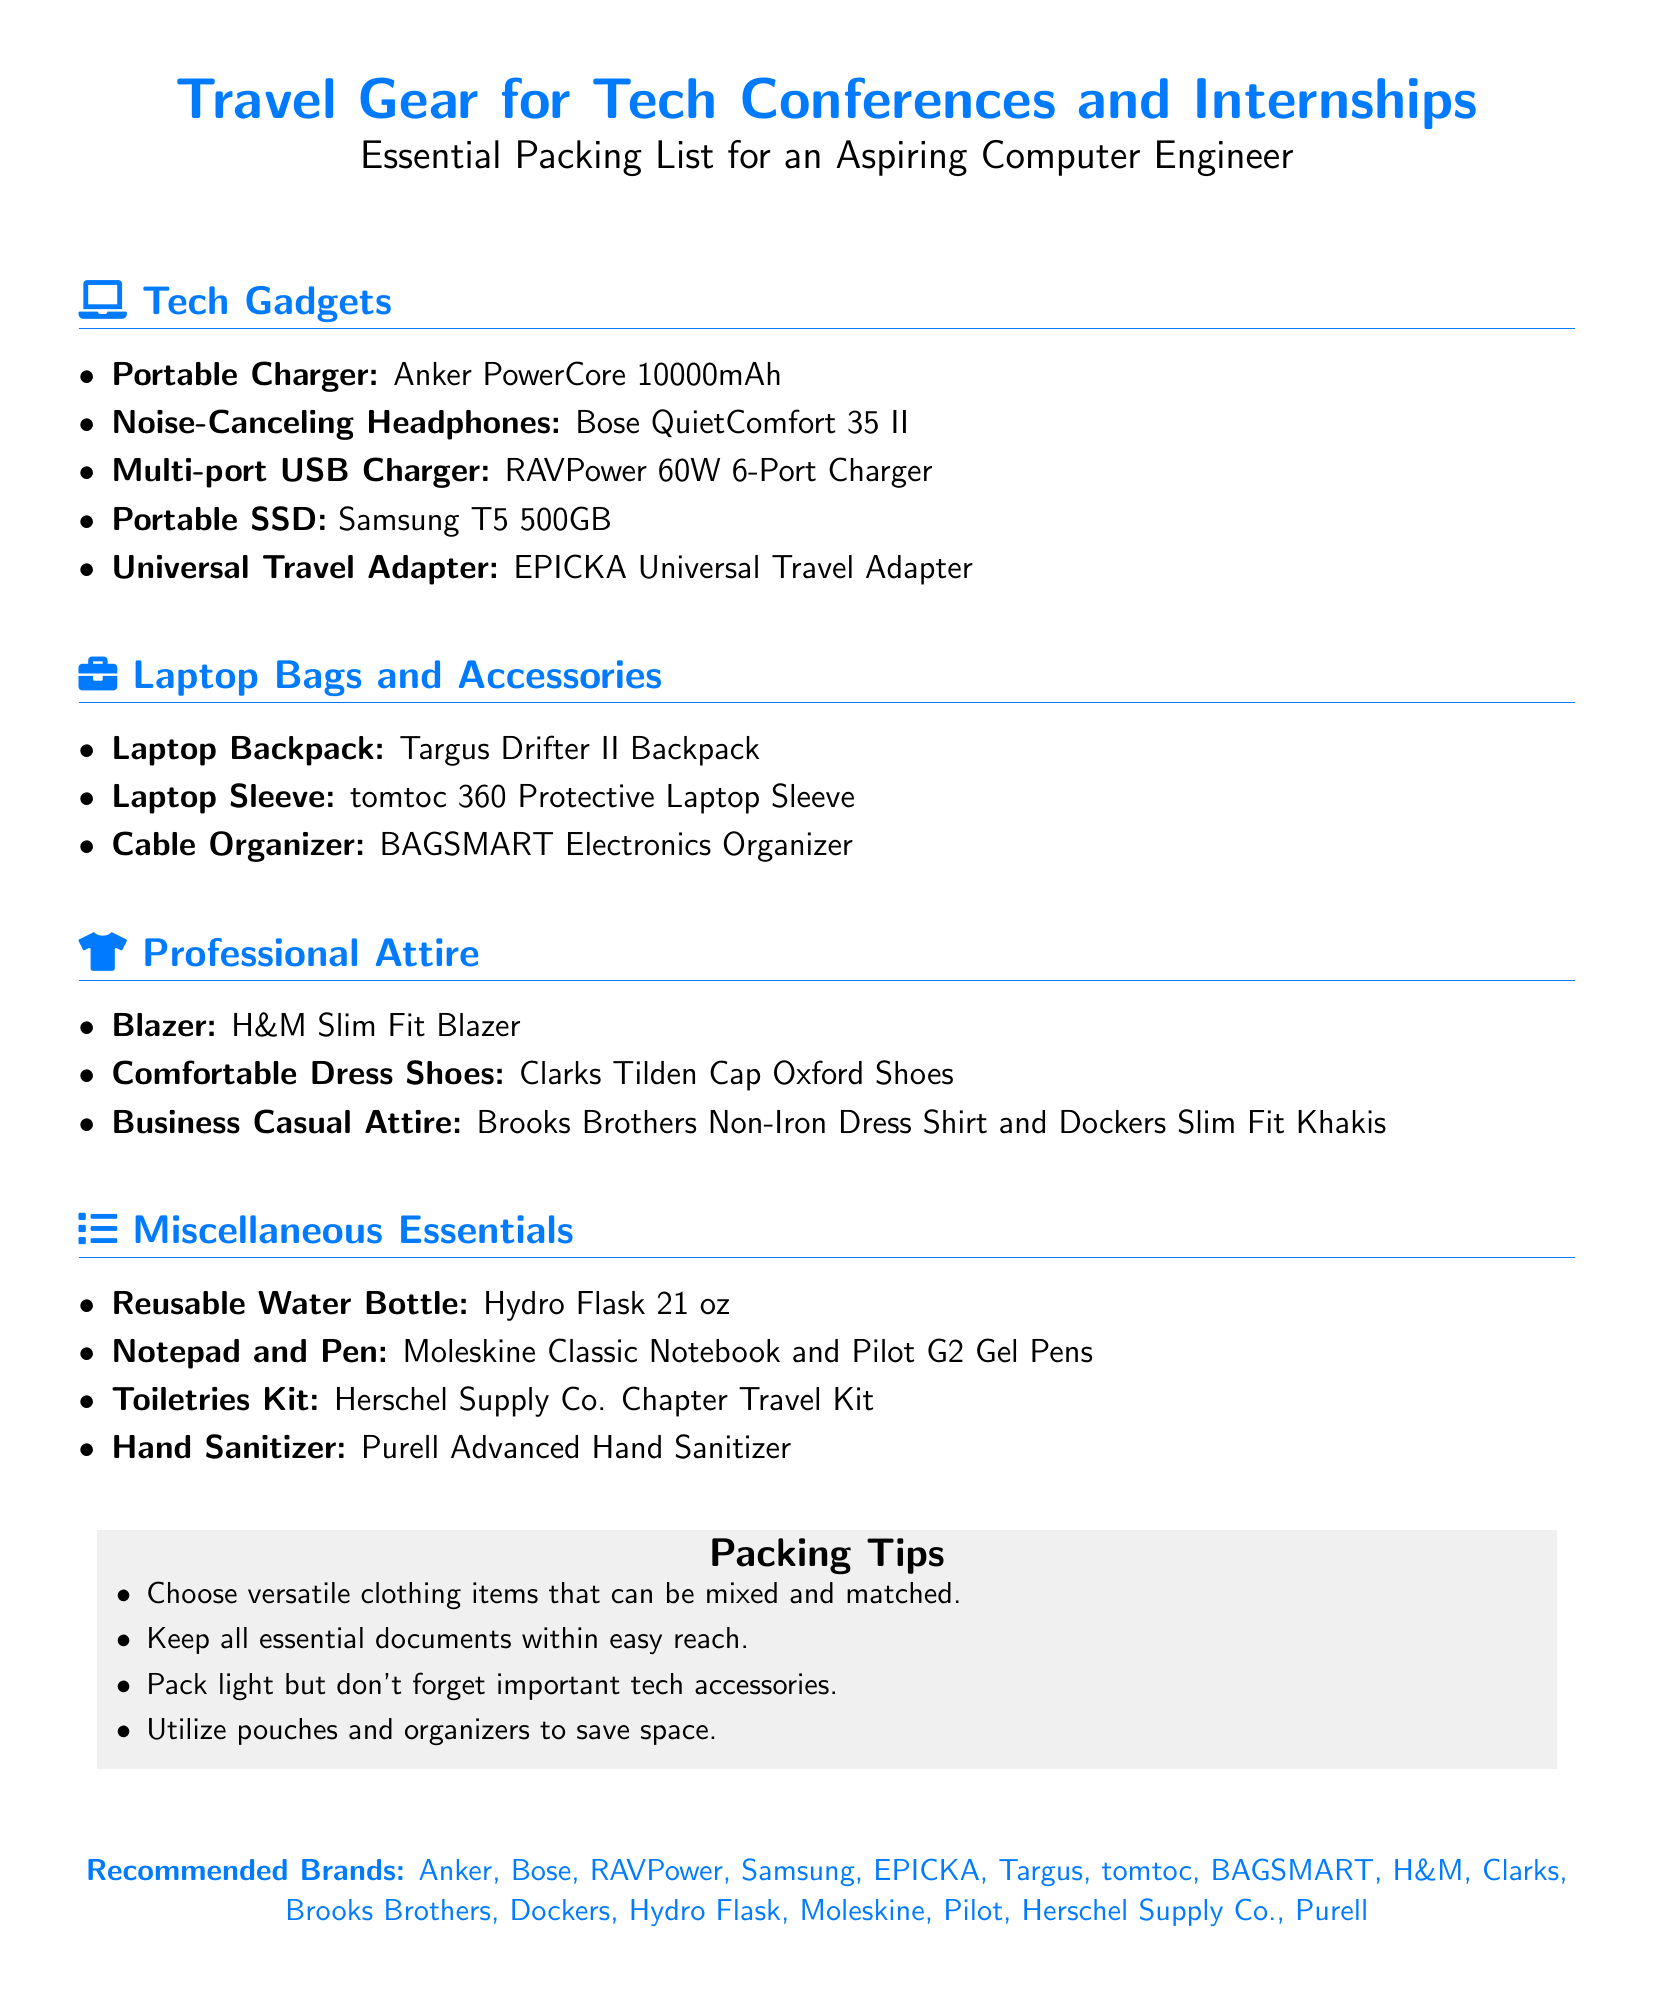what is the recommended portable charger? The document lists the Anker PowerCore 10000mAh as the recommended portable charger.
Answer: Anker PowerCore 10000mAh which brand is suggested for noise-canceling headphones? The recommended brand for noise-canceling headphones in the document is Bose.
Answer: Bose how many items are listed under Tech Gadgets? There are five items listed under the Tech Gadgets section in the document.
Answer: 5 what is a packing tip mentioned in the document? One of the tips mentioned in the document is to choose versatile clothing items that can be mixed and matched.
Answer: Choose versatile clothing items which professional attire item is suggested for comfortable dress shoes? The document recommends Clarks Tilden Cap Oxford Shoes for comfortable dress shoes.
Answer: Clarks Tilden Cap Oxford Shoes what is the name of the travel adapter recommended? The EPICKA Universal Travel Adapter is the recommended travel adapter mentioned in the document.
Answer: EPICKA Universal Travel Adapter name one item listed under Miscellaneous Essentials. The document lists the Hydro Flask 21 oz as one item under Miscellaneous Essentials.
Answer: Hydro Flask 21 oz what is the total number of sections in the document? The document has four main sections: Tech Gadgets, Laptop Bags and Accessories, Professional Attire, and Miscellaneous Essentials.
Answer: 4 which brand is mentioned for toiletries kit? The recommended brand for toiletries kit in the document is Herschel Supply Co.
Answer: Herschel Supply Co 